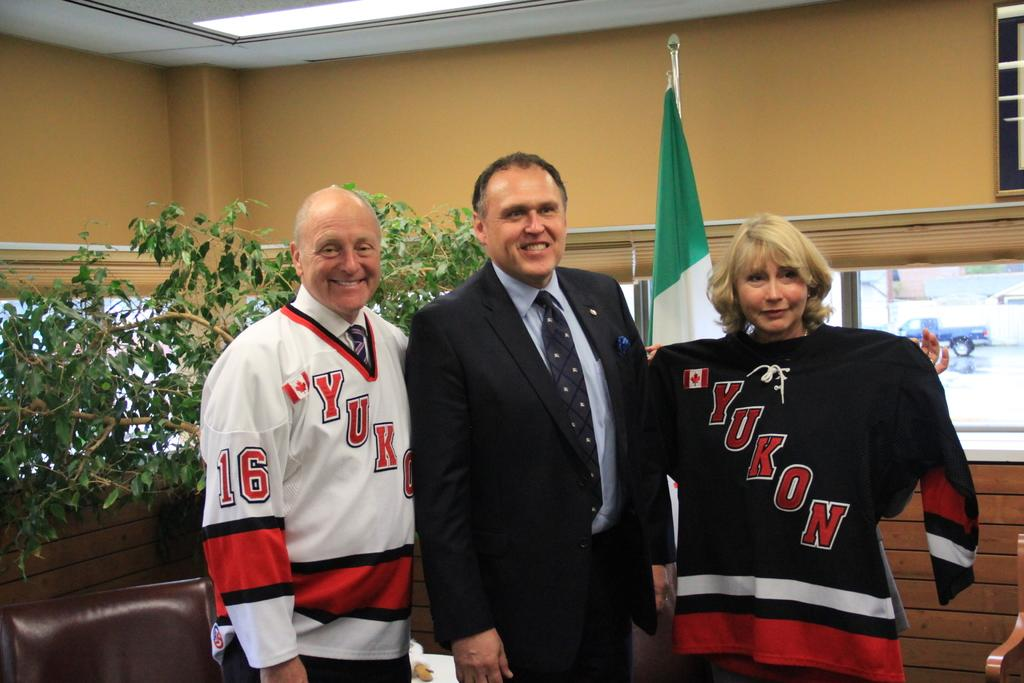<image>
Describe the image concisely. Three people pose for a picture, two of them wearing Yukon jerseys. 